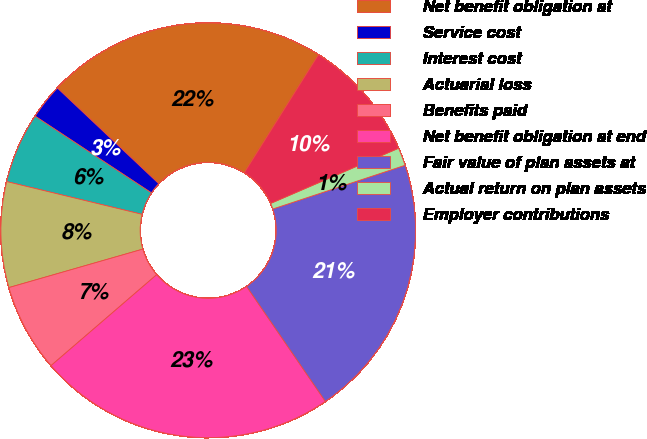Convert chart. <chart><loc_0><loc_0><loc_500><loc_500><pie_chart><fcel>Net benefit obligation at<fcel>Service cost<fcel>Interest cost<fcel>Actuarial loss<fcel>Benefits paid<fcel>Net benefit obligation at end<fcel>Fair value of plan assets at<fcel>Actual return on plan assets<fcel>Employer contributions<nl><fcel>21.89%<fcel>2.76%<fcel>5.5%<fcel>8.23%<fcel>6.86%<fcel>23.25%<fcel>20.52%<fcel>1.4%<fcel>9.59%<nl></chart> 